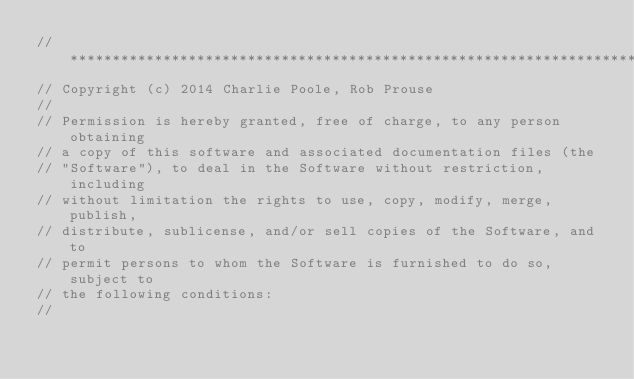Convert code to text. <code><loc_0><loc_0><loc_500><loc_500><_C#_>// ***********************************************************************
// Copyright (c) 2014 Charlie Poole, Rob Prouse
//
// Permission is hereby granted, free of charge, to any person obtaining
// a copy of this software and associated documentation files (the
// "Software"), to deal in the Software without restriction, including
// without limitation the rights to use, copy, modify, merge, publish,
// distribute, sublicense, and/or sell copies of the Software, and to
// permit persons to whom the Software is furnished to do so, subject to
// the following conditions:
//</code> 